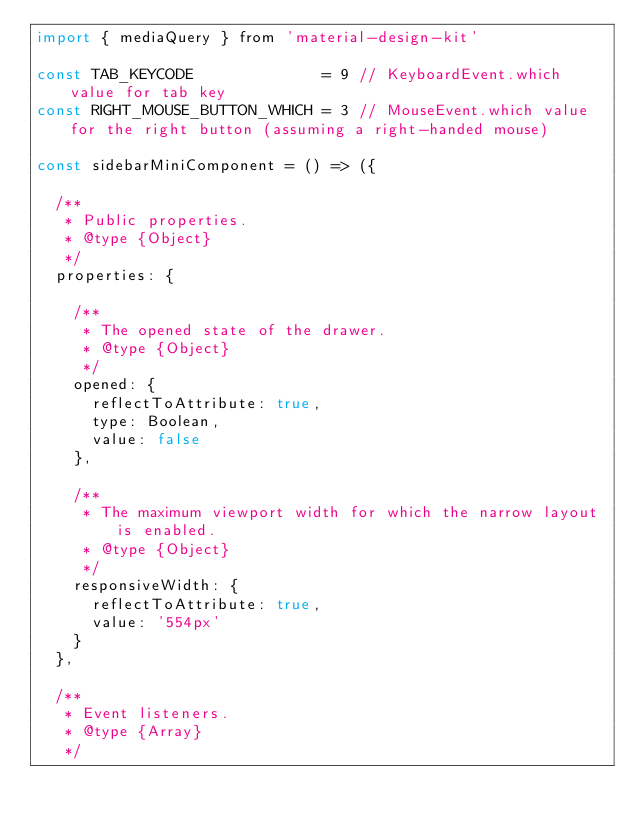<code> <loc_0><loc_0><loc_500><loc_500><_JavaScript_>import { mediaQuery } from 'material-design-kit'

const TAB_KEYCODE              = 9 // KeyboardEvent.which value for tab key
const RIGHT_MOUSE_BUTTON_WHICH = 3 // MouseEvent.which value for the right button (assuming a right-handed mouse)

const sidebarMiniComponent = () => ({

  /**
   * Public properties.
   * @type {Object}
   */
  properties: {

    /**
     * The opened state of the drawer.
     * @type {Object}
     */
    opened: {
      reflectToAttribute: true,
      type: Boolean,
      value: false
    },

    /**
     * The maximum viewport width for which the narrow layout is enabled.
     * @type {Object}
     */
    responsiveWidth: {
      reflectToAttribute: true,
      value: '554px'
    }
  },

  /**
   * Event listeners.
   * @type {Array}
   */</code> 